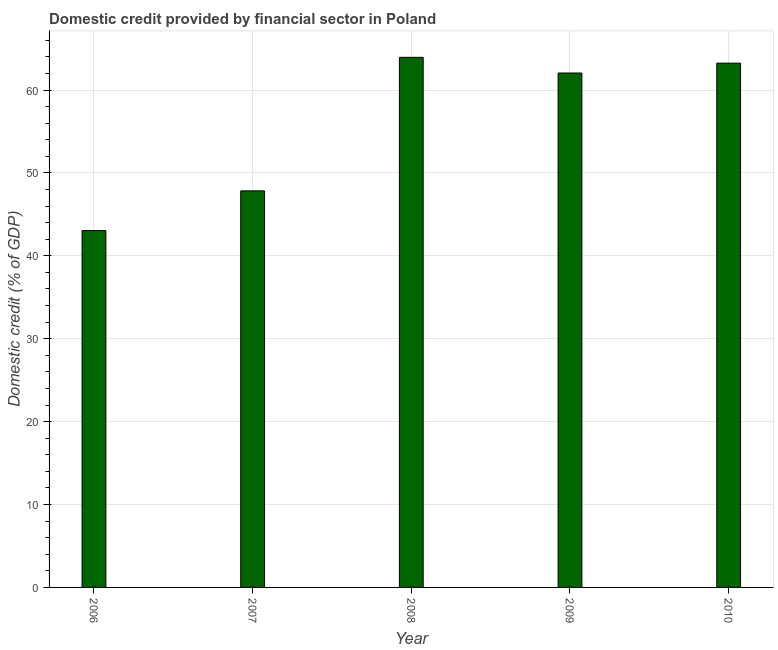Does the graph contain any zero values?
Give a very brief answer. No. Does the graph contain grids?
Give a very brief answer. Yes. What is the title of the graph?
Provide a succinct answer. Domestic credit provided by financial sector in Poland. What is the label or title of the Y-axis?
Make the answer very short. Domestic credit (% of GDP). What is the domestic credit provided by financial sector in 2007?
Make the answer very short. 47.84. Across all years, what is the maximum domestic credit provided by financial sector?
Make the answer very short. 63.95. Across all years, what is the minimum domestic credit provided by financial sector?
Provide a succinct answer. 43.04. In which year was the domestic credit provided by financial sector maximum?
Offer a terse response. 2008. What is the sum of the domestic credit provided by financial sector?
Provide a short and direct response. 280.12. What is the difference between the domestic credit provided by financial sector in 2006 and 2010?
Your answer should be compact. -20.2. What is the average domestic credit provided by financial sector per year?
Provide a succinct answer. 56.02. What is the median domestic credit provided by financial sector?
Ensure brevity in your answer.  62.05. Do a majority of the years between 2009 and 2007 (inclusive) have domestic credit provided by financial sector greater than 48 %?
Provide a short and direct response. Yes. What is the ratio of the domestic credit provided by financial sector in 2008 to that in 2009?
Your response must be concise. 1.03. Is the domestic credit provided by financial sector in 2006 less than that in 2009?
Make the answer very short. Yes. What is the difference between the highest and the second highest domestic credit provided by financial sector?
Keep it short and to the point. 0.7. Is the sum of the domestic credit provided by financial sector in 2007 and 2010 greater than the maximum domestic credit provided by financial sector across all years?
Your answer should be compact. Yes. What is the difference between the highest and the lowest domestic credit provided by financial sector?
Ensure brevity in your answer.  20.9. In how many years, is the domestic credit provided by financial sector greater than the average domestic credit provided by financial sector taken over all years?
Make the answer very short. 3. Are all the bars in the graph horizontal?
Give a very brief answer. No. How many years are there in the graph?
Offer a terse response. 5. What is the Domestic credit (% of GDP) of 2006?
Your response must be concise. 43.04. What is the Domestic credit (% of GDP) of 2007?
Keep it short and to the point. 47.84. What is the Domestic credit (% of GDP) of 2008?
Offer a very short reply. 63.95. What is the Domestic credit (% of GDP) in 2009?
Make the answer very short. 62.05. What is the Domestic credit (% of GDP) in 2010?
Your answer should be very brief. 63.24. What is the difference between the Domestic credit (% of GDP) in 2006 and 2007?
Give a very brief answer. -4.79. What is the difference between the Domestic credit (% of GDP) in 2006 and 2008?
Offer a very short reply. -20.9. What is the difference between the Domestic credit (% of GDP) in 2006 and 2009?
Keep it short and to the point. -19.01. What is the difference between the Domestic credit (% of GDP) in 2006 and 2010?
Ensure brevity in your answer.  -20.2. What is the difference between the Domestic credit (% of GDP) in 2007 and 2008?
Ensure brevity in your answer.  -16.11. What is the difference between the Domestic credit (% of GDP) in 2007 and 2009?
Your answer should be very brief. -14.22. What is the difference between the Domestic credit (% of GDP) in 2007 and 2010?
Offer a very short reply. -15.4. What is the difference between the Domestic credit (% of GDP) in 2008 and 2009?
Your answer should be very brief. 1.89. What is the difference between the Domestic credit (% of GDP) in 2008 and 2010?
Give a very brief answer. 0.7. What is the difference between the Domestic credit (% of GDP) in 2009 and 2010?
Your answer should be compact. -1.19. What is the ratio of the Domestic credit (% of GDP) in 2006 to that in 2007?
Provide a succinct answer. 0.9. What is the ratio of the Domestic credit (% of GDP) in 2006 to that in 2008?
Ensure brevity in your answer.  0.67. What is the ratio of the Domestic credit (% of GDP) in 2006 to that in 2009?
Your answer should be very brief. 0.69. What is the ratio of the Domestic credit (% of GDP) in 2006 to that in 2010?
Offer a very short reply. 0.68. What is the ratio of the Domestic credit (% of GDP) in 2007 to that in 2008?
Offer a terse response. 0.75. What is the ratio of the Domestic credit (% of GDP) in 2007 to that in 2009?
Give a very brief answer. 0.77. What is the ratio of the Domestic credit (% of GDP) in 2007 to that in 2010?
Offer a terse response. 0.76. What is the ratio of the Domestic credit (% of GDP) in 2008 to that in 2009?
Make the answer very short. 1.03. What is the ratio of the Domestic credit (% of GDP) in 2008 to that in 2010?
Keep it short and to the point. 1.01. 